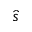Convert formula to latex. <formula><loc_0><loc_0><loc_500><loc_500>\hat { s }</formula> 